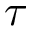<formula> <loc_0><loc_0><loc_500><loc_500>\tau</formula> 